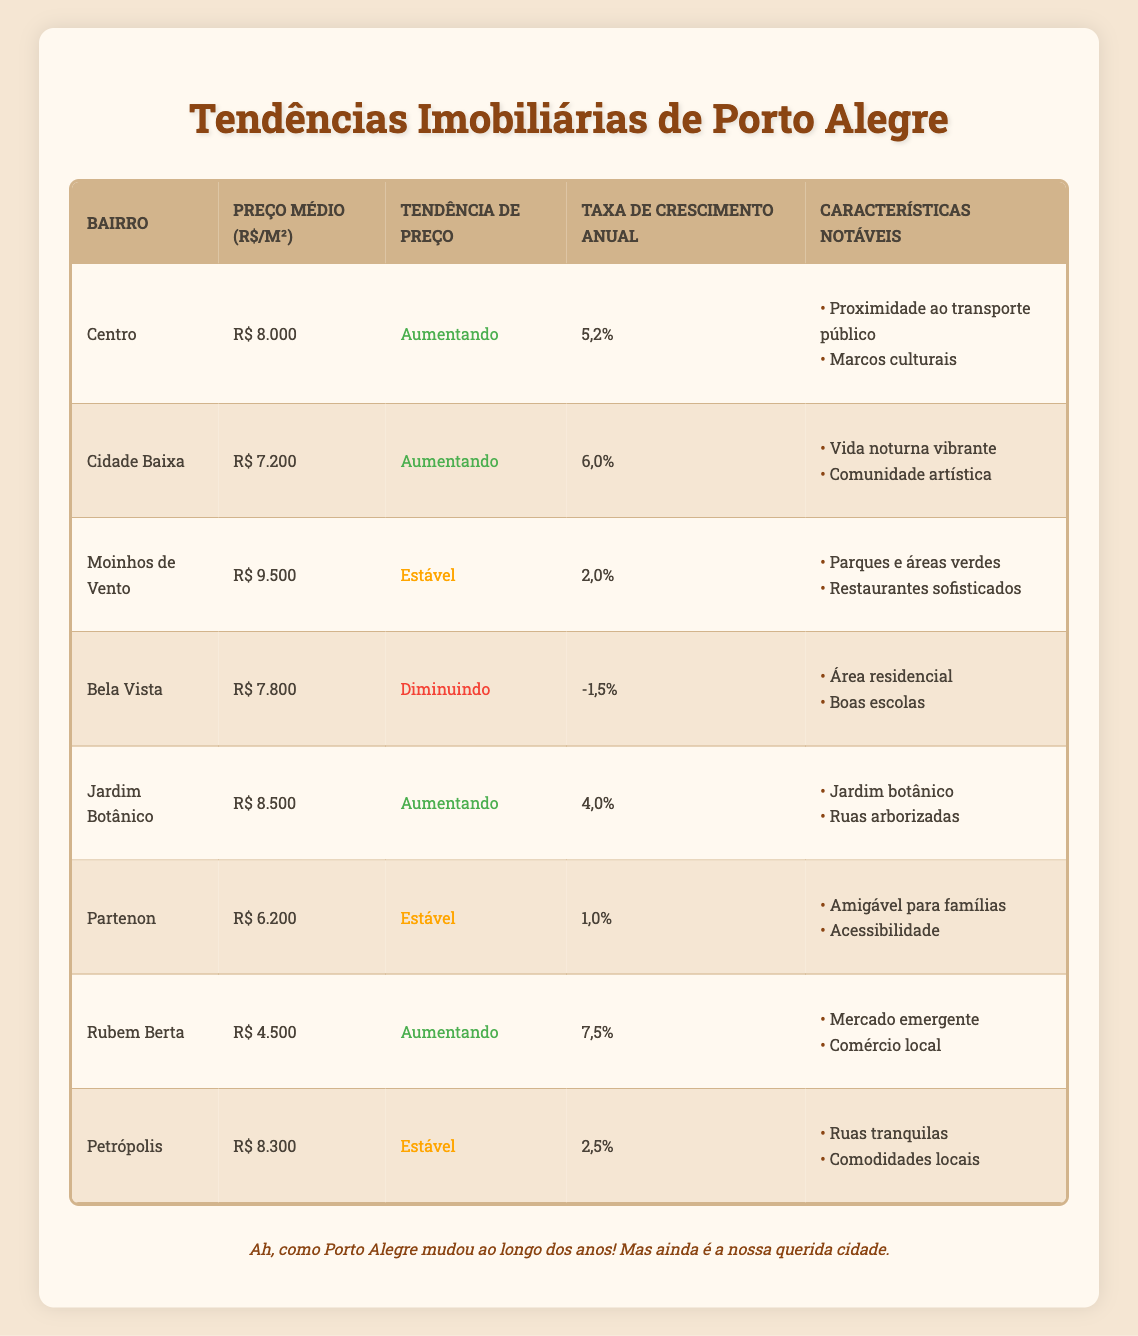What is the average price per square meter in the Centro neighborhood? The table shows that the average price per square meter in the Centro neighborhood is R$ 8.000.
Answer: R$ 8.000 Which neighborhood has the highest average price per square meter? By examining the table, Moinhos de Vento has the highest average price per square meter at R$ 9.500.
Answer: Moinhos de Vento Is the price trend in Jardim Botânico increasing or decreasing? The table indicates that the price trend in Jardim Botânico is increasing, as listed under the price trend column.
Answer: Increasing How much lower is the average price per square meter in Rubem Berta compared to Moinhos de Vento? The average price in Moinhos de Vento is R$ 9.500, while in Rubem Berta it is R$ 4.500. Therefore, the difference is R$ 9.500 - R$ 4.500 = R$ 5.000.
Answer: R$ 5.000 How many neighborhoods have a stable price trend? Referring to the table, there are three neighborhoods with a stable price trend: Moinhos de Vento, Partenon, and Petrópolis.
Answer: 3 What is the combined average price per square meter of the neighborhoods with increasing price trends? The neighborhoods with increasing price trends and their average prices are: Centro (R$ 8.000), Cidade Baixa (R$ 7.200), Jardim Botânico (R$ 8.500), and Rubem Berta (R$ 4.500). The total is R$ 8.000 + R$ 7.200 + R$ 8.500 + R$ 4.500 = R$ 28.200. To find the average, divide by 4, giving an average of R$ 28.200 / 4 = R$ 7.050.
Answer: R$ 7.050 Does the Bela Vista neighborhood have a better price trend than Partenon? The price trend for Bela Vista is decreasing, while for Partenon it is stable. Since stable is better than decreasing, the answer is yes, Partenon has a better price trend than Bela Vista.
Answer: Yes What notable feature is shared by Jardim Botânico and Moinhos de Vento? Both neighborhoods are noted for having parks and green spaces as their notable feature listed in the respective table cells.
Answer: Parks and green spaces 